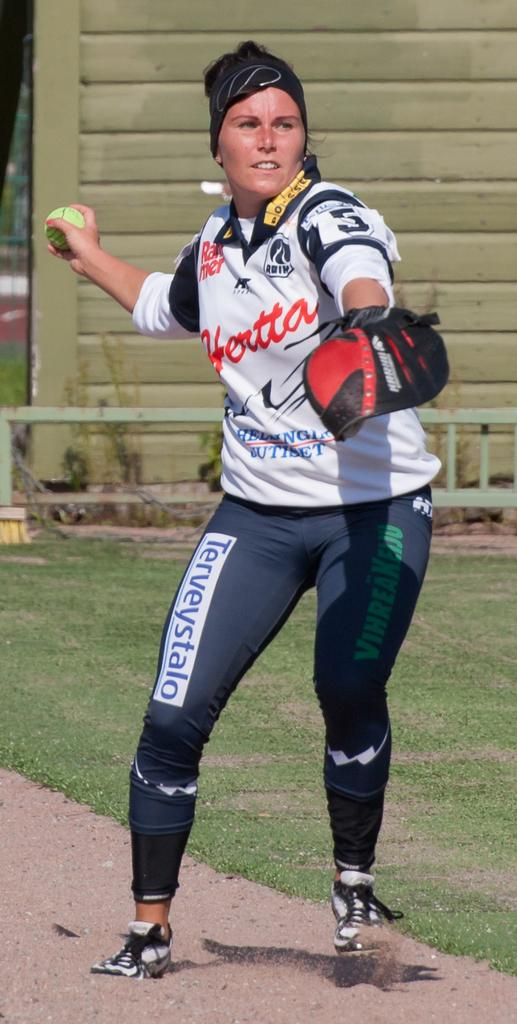<image>
Create a compact narrative representing the image presented. A woman in pants that say Terveystalo on them gets ready to throw a ball. 